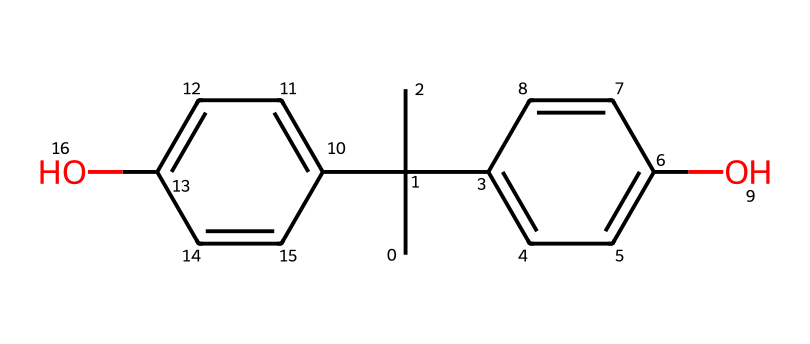What is the molecular formula of bisphenol A? The SMILES representation indicates that there are 15 carbon atoms, 16 hydrogen atoms, and 2 oxygen atoms in the molecule. This can be derived directly from counting the relevant atoms represented in the SMILES string.
Answer: C15H16O2 How many chiral centers does bisphenol A have? A chiral center is typically a carbon atom that has four different substituents. In the provided structure, there are two specific carbon atoms that meet this criterion based on their connections, making them chiral centers.
Answer: 2 What functional groups are present in bisphenol A? The chemical structure contains hydroxyl groups (-OH) indicated by the "O" in the SMILES string and the surrounding carbon atoms, which confirm they are attached to aromatic rings.
Answer: hydroxyl groups Are there any rings in the structure of bisphenol A? The structure includes two aromatic rings, which are evident from the multiple bonds and alternating single and double bonds within the cyclic parts of the compound.
Answer: yes What type of stereoisomerism does bisphenol A exhibit? Bisphenol A with its chiral centers can show optical isomerism, which involves the presence of non-superimposable mirror images because of the specific spatial arrangement of the atoms around its chiral centers.
Answer: optical isomerism What is the role of bisphenol A in electrical insulation materials? Bisphenol A is used as a base for epoxy resins, which provide excellent electrical insulation properties, making it an essential component in insulating materials for electrical applications.
Answer: base for epoxy resins 